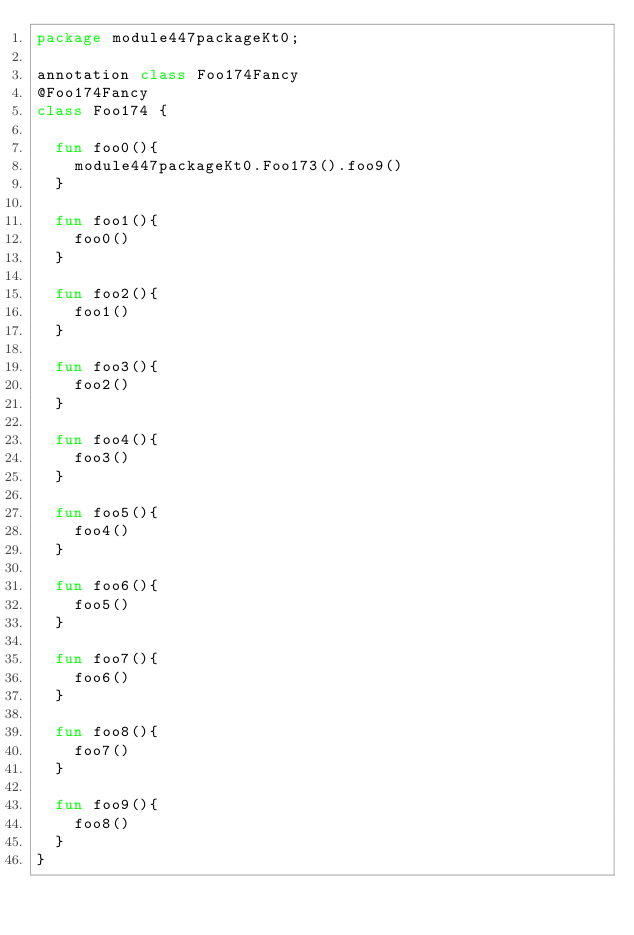<code> <loc_0><loc_0><loc_500><loc_500><_Kotlin_>package module447packageKt0;

annotation class Foo174Fancy
@Foo174Fancy
class Foo174 {

  fun foo0(){
    module447packageKt0.Foo173().foo9()
  }

  fun foo1(){
    foo0()
  }

  fun foo2(){
    foo1()
  }

  fun foo3(){
    foo2()
  }

  fun foo4(){
    foo3()
  }

  fun foo5(){
    foo4()
  }

  fun foo6(){
    foo5()
  }

  fun foo7(){
    foo6()
  }

  fun foo8(){
    foo7()
  }

  fun foo9(){
    foo8()
  }
}</code> 